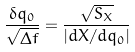<formula> <loc_0><loc_0><loc_500><loc_500>\frac { \delta q _ { 0 } } { \sqrt { \Delta f } } = \frac { \sqrt { S _ { X } } } { | d X / d q _ { 0 } | }</formula> 